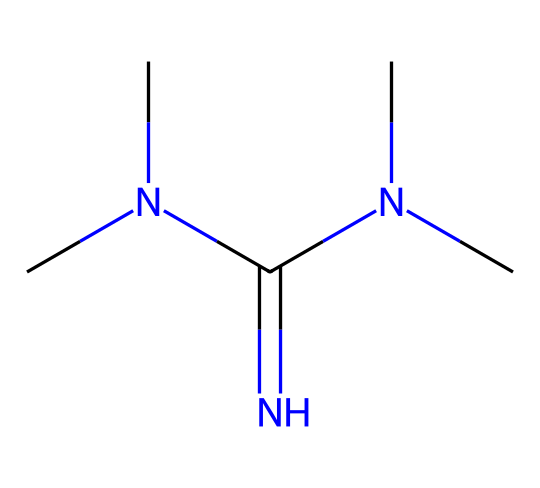What is the molecular formula of tetramethylguanidine? By examining the structure represented by the SMILES, we can count the number of carbon (C), hydrogen (H), nitrogen (N), and oxygen (O) atoms. In total, there are 6 carbon atoms, 15 hydrogen atoms, and 2 nitrogen atoms, leading to the formula C6H15N5.
Answer: C6H15N5 How many nitrogen atoms are present in tetramethylguanidine? Moving through the SMILES representation, we identify the nitrogen (N) atoms. Specifically, there are two nitrogen atoms attached directly to the guanidine framework and additional nitrogen atoms from the three methyl groups. This results in a total of 5 nitrogen atoms.
Answer: 5 What type of base is tetramethylguanidine classified as? Understanding the structure shows that it has a very high electron density, particularly due to the presence of multiple electron-donating alkyl groups. This results in a carbanion-forming strong organic superbase classification.
Answer: organic superbase What is the role of the methyl groups in tetramethylguanidine? The methyl groups enhance the basicity of the molecule by stabilizing proton withdrawal through the inductive effect, resulting in lower pKa values. This increases its ability to accept protons and thus enhances its superbase nature.
Answer: increase basicity What is the pKa value of tetramethylguanidine? Known data suggests that the pKa value of tetramethylguanidine is around 13. For superbases, this relatively high pKa indicates a strong tendency to accept protons, a defining characteristic of superbases.
Answer: 13 Is tetramethylguanidine a strong nucleophile? By analyzing the electron-donating characteristics of the nitrogen atoms coupled with the presence of multiple alkyl groups, we conclude that the electron density is significant, making it a very strong nucleophile.
Answer: yes 